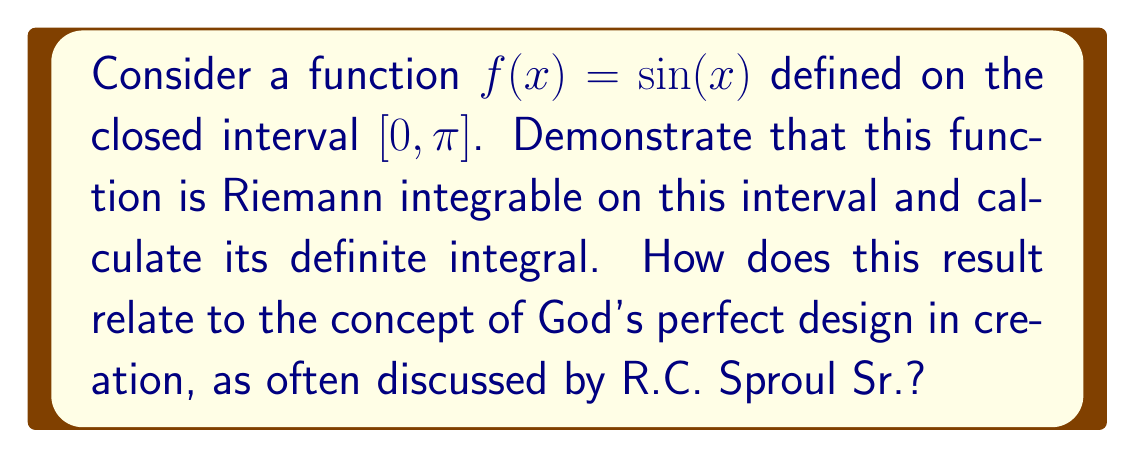Solve this math problem. To demonstrate that $f(x) = \sin(x)$ is Riemann integrable on $[0, \pi]$ and calculate its definite integral, we'll follow these steps:

1) First, we need to show that $f(x) = \sin(x)$ is Riemann integrable on $[0, \pi]$. A function is Riemann integrable on a closed interval if it is bounded and continuous on that interval (except possibly at a finite number of points).

   - $\sin(x)$ is continuous on all real numbers, including $[0, \pi]$.
   - $\sin(x)$ is bounded on $[0, \pi]$ as $-1 \leq \sin(x) \leq 1$ for all $x$.

   Therefore, $\sin(x)$ is Riemann integrable on $[0, \pi]$.

2) To calculate the definite integral, we can use the Fundamental Theorem of Calculus:

   $$\int_0^\pi \sin(x) dx = [-\cos(x)]_0^\pi = -\cos(\pi) - (-\cos(0))$$

3) Evaluating this:
   
   $$-\cos(\pi) - (-\cos(0)) = -(-1) - (-1) = 1 + 1 = 2$$

4) Therefore, $\int_0^\pi \sin(x) dx = 2$.

Relating this to R.C. Sproul Sr.'s teachings:

The perfect, precise result of this integral (exactly 2) could be seen as a reflection of God's orderly design in creation. Sproul often spoke about how the laws of nature and mathematics reflect God's character - consistent, reliable, and beautiful in their precision. The sine function, with its perfect oscillation and this exact integral result, exemplifies the kind of mathematical harmony that Sproul might point to as evidence of a divine Creator's handiwork in the universe.
Answer: The function $f(x) = \sin(x)$ is Riemann integrable on $[0, \pi]$, and its definite integral is:

$$\int_0^\pi \sin(x) dx = 2$$

This result reflects the orderly and precise nature of mathematical laws, which R.C. Sproul Sr. might interpret as evidence of God's perfect design in creation. 